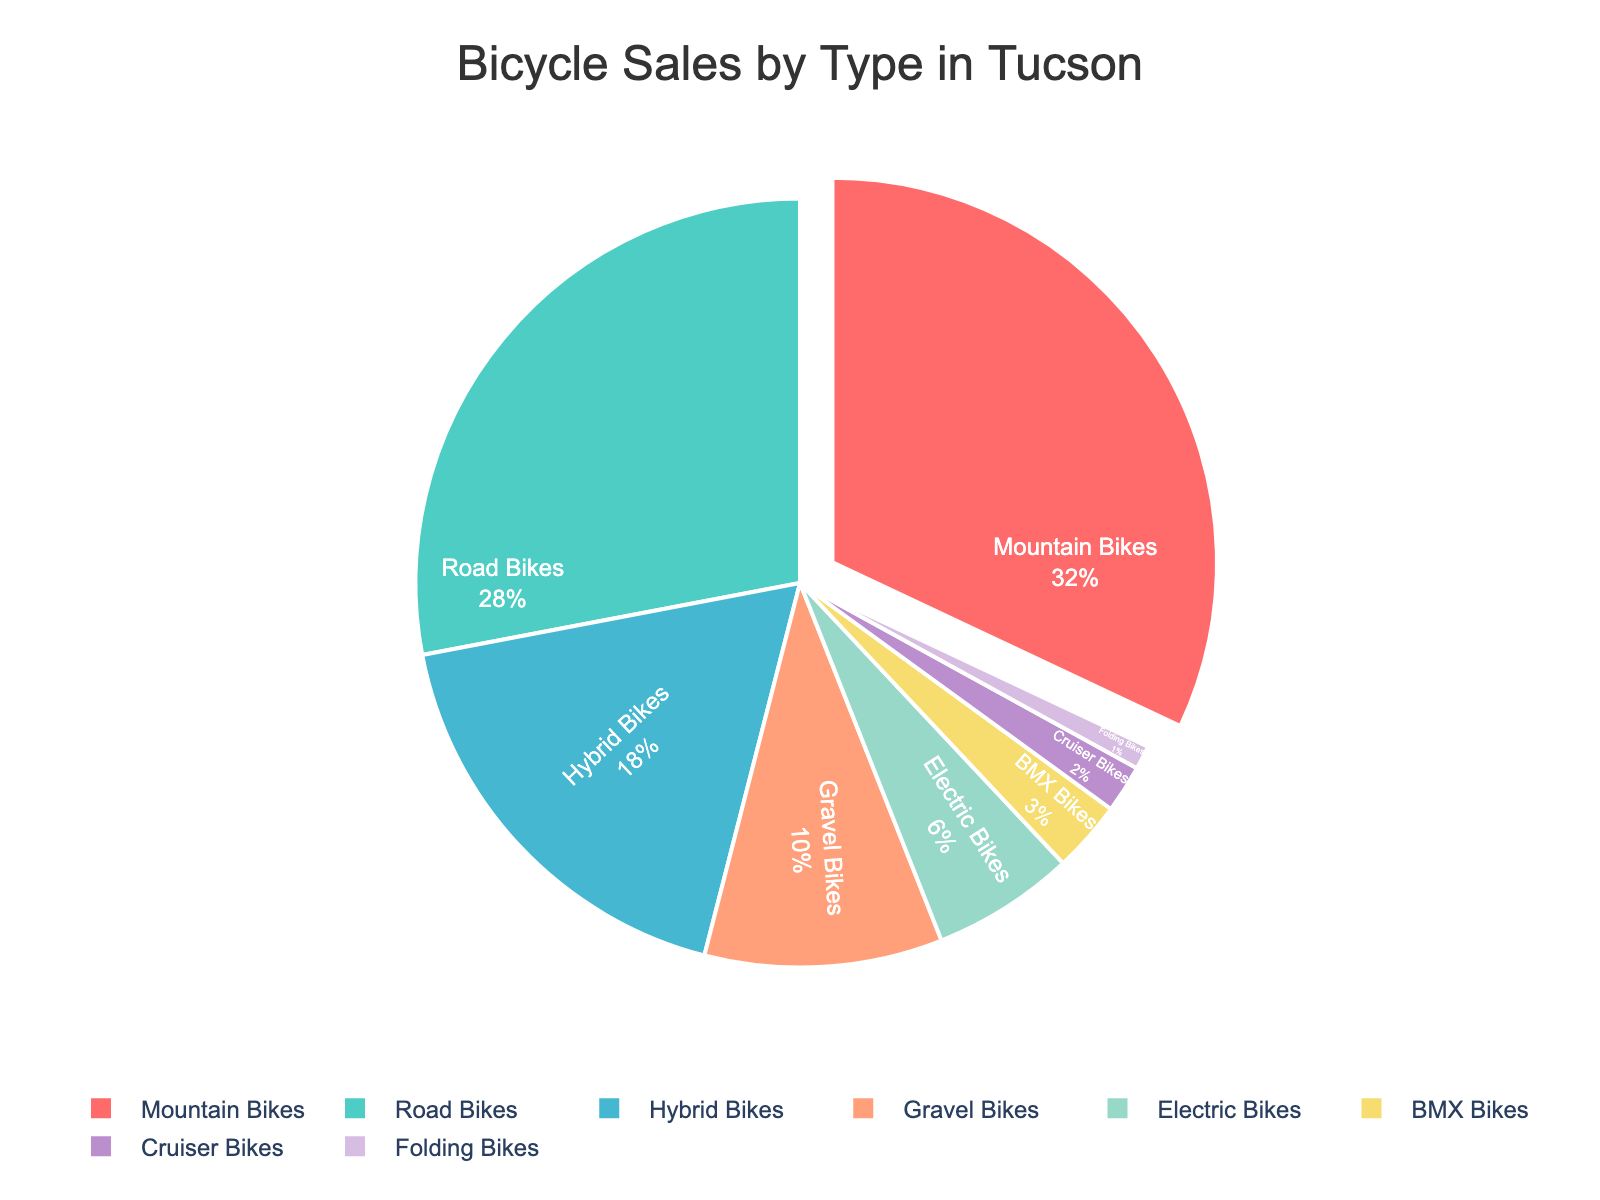Which type of bike has the largest proportion of sales? The largest segment in the pie chart represents Mountain Bikes.
Answer: Mountain Bikes Which two types of bikes together make up over half of all sales? Summing the percentages of Mountain Bikes (32%) and Road Bikes (28%) gives 60%, which is more than half.
Answer: Mountain Bikes and Road Bikes What's the percentage difference between Road Bikes and Electric Bikes sales? The sales percentage for Road Bikes is 28%, and for Electric Bikes, it is 6%. The difference is 28% - 6% = 22%.
Answer: 22% Which type of bike has the smallest proportion of sales? The smallest segment in the pie chart represents Folding Bikes.
Answer: Folding Bikes What is the total percentage of sales for BMX Bikes and Cruiser Bikes combined? Summing the percentages of BMX Bikes (3%) and Cruiser Bikes (2%) gives 3% + 2% = 5%.
Answer: 5% Are there more sales of Hybrid Bikes or Gravel Bikes? The chart shows that Hybrid Bikes have 18% of sales while Gravel Bikes have 10%, so Hybrid Bikes have more sales.
Answer: Hybrid Bikes What portion of the sales do bikes other than Mountain and Road Bikes account for? Adding up the percentages for non-Mountain and non-Road bikes: Hybrid Bikes (18%) + Gravel Bikes (10%) + Electric Bikes (6%) + BMX Bikes (3%) + Cruiser Bikes (2%) + Folding Bikes (1%) = 40%.
Answer: 40% What is the combined sales percentage for Gravel Bikes and Electric Bikes? Summing the percentages of Gravel Bikes (10%) and Electric Bikes (6%) gives 10% + 6% = 16%.
Answer: 16% How many types of bikes have less than 10% of the sales? The types with less than 10% are Electric Bikes (6%), BMX Bikes (3%), Cruiser Bikes (2%), and Folding Bikes (1%), totaling four types.
Answer: 4 types 